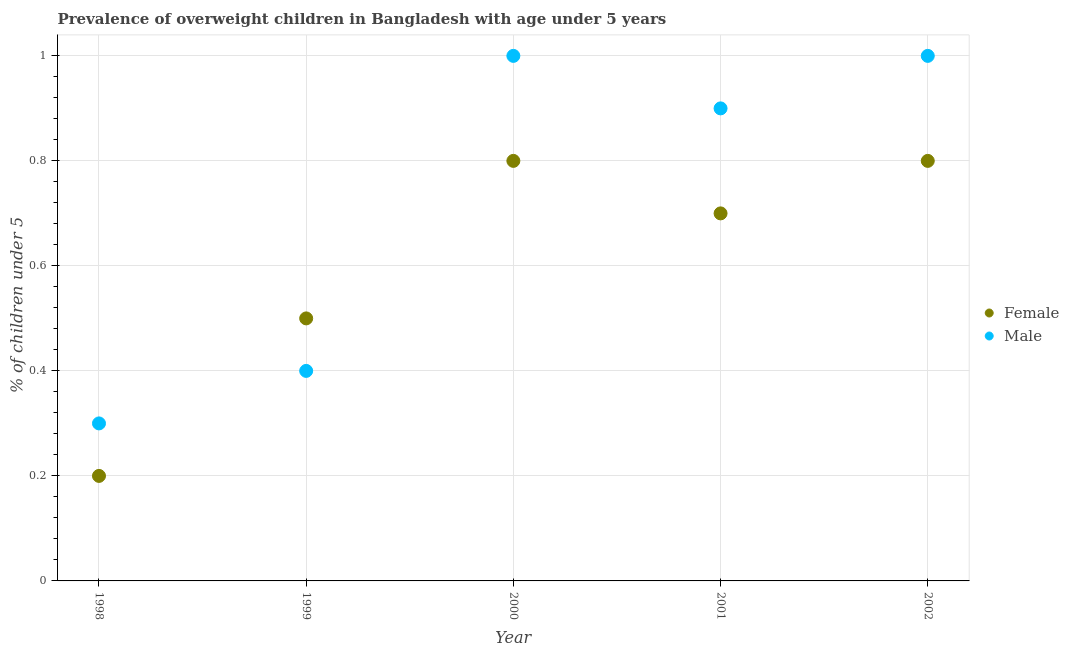How many different coloured dotlines are there?
Your answer should be compact. 2. What is the percentage of obese male children in 1999?
Provide a succinct answer. 0.4. Across all years, what is the maximum percentage of obese female children?
Offer a terse response. 0.8. Across all years, what is the minimum percentage of obese female children?
Offer a terse response. 0.2. What is the total percentage of obese male children in the graph?
Make the answer very short. 3.6. What is the difference between the percentage of obese female children in 1998 and that in 2000?
Offer a very short reply. -0.6. What is the difference between the percentage of obese female children in 2001 and the percentage of obese male children in 1998?
Make the answer very short. 0.4. What is the average percentage of obese male children per year?
Ensure brevity in your answer.  0.72. In the year 2000, what is the difference between the percentage of obese male children and percentage of obese female children?
Offer a very short reply. 0.2. In how many years, is the percentage of obese male children greater than 0.12 %?
Offer a terse response. 5. What is the ratio of the percentage of obese male children in 1999 to that in 2001?
Keep it short and to the point. 0.44. Is the difference between the percentage of obese female children in 1998 and 2001 greater than the difference between the percentage of obese male children in 1998 and 2001?
Keep it short and to the point. Yes. What is the difference between the highest and the second highest percentage of obese male children?
Give a very brief answer. 0. What is the difference between the highest and the lowest percentage of obese female children?
Ensure brevity in your answer.  0.6. In how many years, is the percentage of obese male children greater than the average percentage of obese male children taken over all years?
Ensure brevity in your answer.  3. Does the percentage of obese female children monotonically increase over the years?
Your answer should be compact. No. How many dotlines are there?
Ensure brevity in your answer.  2. How many years are there in the graph?
Your answer should be compact. 5. Does the graph contain grids?
Provide a short and direct response. Yes. What is the title of the graph?
Keep it short and to the point. Prevalence of overweight children in Bangladesh with age under 5 years. What is the label or title of the X-axis?
Provide a short and direct response. Year. What is the label or title of the Y-axis?
Your answer should be compact.  % of children under 5. What is the  % of children under 5 of Female in 1998?
Your response must be concise. 0.2. What is the  % of children under 5 in Male in 1998?
Your answer should be very brief. 0.3. What is the  % of children under 5 of Female in 1999?
Provide a succinct answer. 0.5. What is the  % of children under 5 in Male in 1999?
Make the answer very short. 0.4. What is the  % of children under 5 of Female in 2000?
Your answer should be very brief. 0.8. What is the  % of children under 5 in Female in 2001?
Give a very brief answer. 0.7. What is the  % of children under 5 in Male in 2001?
Your answer should be compact. 0.9. What is the  % of children under 5 of Female in 2002?
Your response must be concise. 0.8. What is the  % of children under 5 in Male in 2002?
Offer a very short reply. 1. Across all years, what is the maximum  % of children under 5 in Female?
Keep it short and to the point. 0.8. Across all years, what is the minimum  % of children under 5 in Female?
Give a very brief answer. 0.2. Across all years, what is the minimum  % of children under 5 of Male?
Your answer should be very brief. 0.3. What is the total  % of children under 5 in Female in the graph?
Offer a terse response. 3. What is the difference between the  % of children under 5 in Female in 1998 and that in 1999?
Your response must be concise. -0.3. What is the difference between the  % of children under 5 in Female in 1998 and that in 2001?
Offer a very short reply. -0.5. What is the difference between the  % of children under 5 in Male in 1998 and that in 2001?
Offer a terse response. -0.6. What is the difference between the  % of children under 5 in Male in 1998 and that in 2002?
Your response must be concise. -0.7. What is the difference between the  % of children under 5 of Female in 1999 and that in 2001?
Keep it short and to the point. -0.2. What is the difference between the  % of children under 5 in Male in 1999 and that in 2002?
Provide a short and direct response. -0.6. What is the difference between the  % of children under 5 in Female in 2000 and that in 2001?
Make the answer very short. 0.1. What is the difference between the  % of children under 5 in Male in 2000 and that in 2001?
Your answer should be compact. 0.1. What is the difference between the  % of children under 5 in Female in 2000 and that in 2002?
Make the answer very short. 0. What is the difference between the  % of children under 5 of Female in 2001 and that in 2002?
Your response must be concise. -0.1. What is the difference between the  % of children under 5 in Female in 1998 and the  % of children under 5 in Male in 1999?
Your response must be concise. -0.2. What is the difference between the  % of children under 5 in Female in 1998 and the  % of children under 5 in Male in 2000?
Offer a very short reply. -0.8. What is the difference between the  % of children under 5 in Female in 1998 and the  % of children under 5 in Male in 2001?
Ensure brevity in your answer.  -0.7. What is the difference between the  % of children under 5 of Female in 1999 and the  % of children under 5 of Male in 2002?
Make the answer very short. -0.5. What is the difference between the  % of children under 5 in Female in 2000 and the  % of children under 5 in Male in 2001?
Provide a short and direct response. -0.1. What is the difference between the  % of children under 5 of Female in 2001 and the  % of children under 5 of Male in 2002?
Offer a very short reply. -0.3. What is the average  % of children under 5 in Male per year?
Offer a very short reply. 0.72. In the year 1999, what is the difference between the  % of children under 5 in Female and  % of children under 5 in Male?
Offer a terse response. 0.1. In the year 2000, what is the difference between the  % of children under 5 of Female and  % of children under 5 of Male?
Your answer should be very brief. -0.2. What is the ratio of the  % of children under 5 of Female in 1998 to that in 1999?
Provide a short and direct response. 0.4. What is the ratio of the  % of children under 5 in Female in 1998 to that in 2001?
Offer a terse response. 0.29. What is the ratio of the  % of children under 5 in Male in 1998 to that in 2002?
Provide a short and direct response. 0.3. What is the ratio of the  % of children under 5 in Female in 1999 to that in 2000?
Your answer should be very brief. 0.62. What is the ratio of the  % of children under 5 of Male in 1999 to that in 2001?
Your response must be concise. 0.44. What is the ratio of the  % of children under 5 of Female in 1999 to that in 2002?
Offer a very short reply. 0.62. What is the ratio of the  % of children under 5 of Female in 2000 to that in 2001?
Offer a terse response. 1.14. What is the ratio of the  % of children under 5 in Female in 2000 to that in 2002?
Your answer should be compact. 1. What is the ratio of the  % of children under 5 in Male in 2000 to that in 2002?
Your answer should be very brief. 1. What is the ratio of the  % of children under 5 of Male in 2001 to that in 2002?
Your response must be concise. 0.9. What is the difference between the highest and the second highest  % of children under 5 of Female?
Provide a short and direct response. 0. What is the difference between the highest and the lowest  % of children under 5 in Female?
Your answer should be very brief. 0.6. 